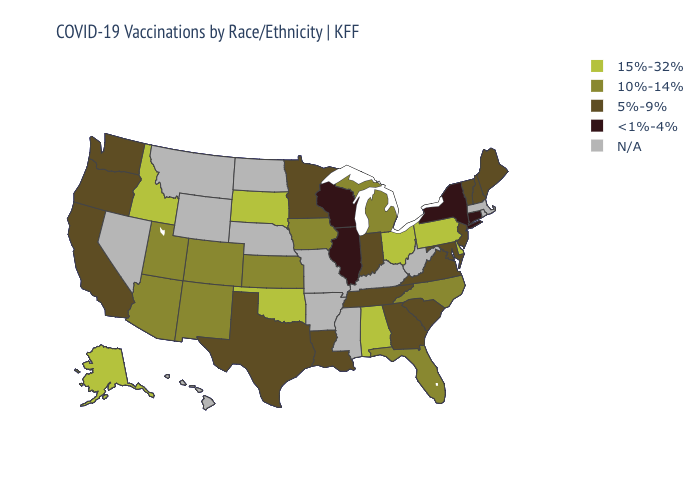What is the value of Illinois?
Be succinct. <1%-4%. Does the map have missing data?
Keep it brief. Yes. Does Wisconsin have the lowest value in the MidWest?
Short answer required. Yes. What is the lowest value in the West?
Keep it brief. 5%-9%. Which states have the lowest value in the MidWest?
Short answer required. Illinois, Wisconsin. Which states have the lowest value in the Northeast?
Short answer required. Connecticut, New York. What is the value of Hawaii?
Be succinct. N/A. Does Illinois have the lowest value in the MidWest?
Quick response, please. Yes. What is the lowest value in the USA?
Quick response, please. <1%-4%. Name the states that have a value in the range <1%-4%?
Keep it brief. Connecticut, Illinois, New York, Wisconsin. Name the states that have a value in the range 5%-9%?
Keep it brief. California, Georgia, Indiana, Louisiana, Maine, Maryland, Minnesota, New Hampshire, New Jersey, Oregon, South Carolina, Tennessee, Texas, Vermont, Virginia, Washington. Does the first symbol in the legend represent the smallest category?
Short answer required. No. Among the states that border Delaware , does New Jersey have the highest value?
Answer briefly. No. What is the value of Ohio?
Keep it brief. 15%-32%. 